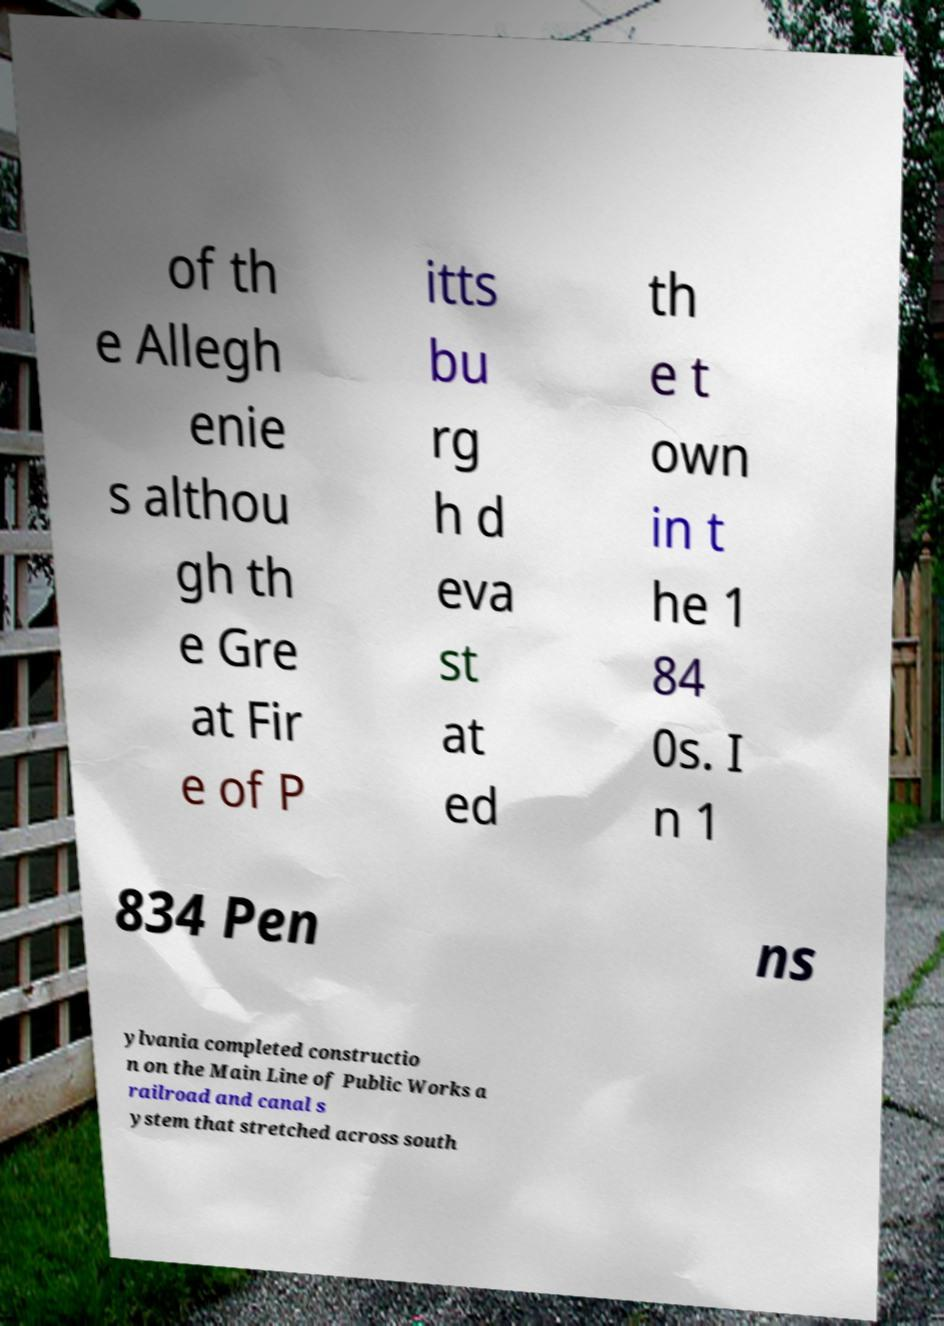Could you extract and type out the text from this image? of th e Allegh enie s althou gh th e Gre at Fir e of P itts bu rg h d eva st at ed th e t own in t he 1 84 0s. I n 1 834 Pen ns ylvania completed constructio n on the Main Line of Public Works a railroad and canal s ystem that stretched across south 